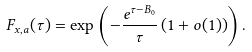Convert formula to latex. <formula><loc_0><loc_0><loc_500><loc_500>F _ { x , a } ( \tau ) = \exp \left ( - \frac { e ^ { \tau - B _ { 0 } } } { \tau } \left ( 1 + o ( 1 ) \right ) \right ) .</formula> 